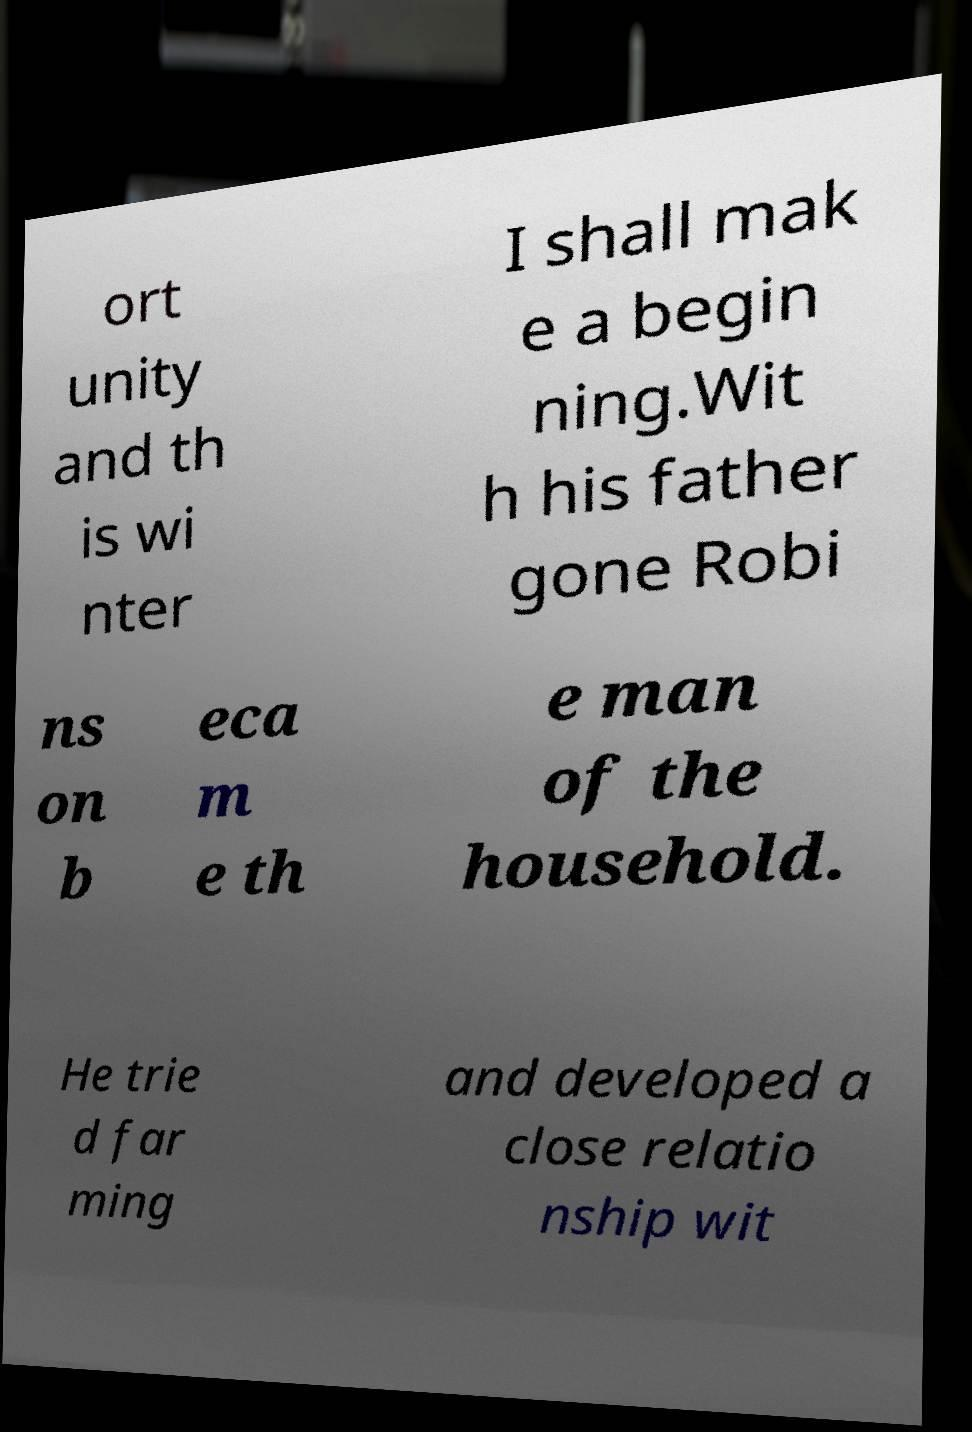Please read and relay the text visible in this image. What does it say? ort unity and th is wi nter I shall mak e a begin ning.Wit h his father gone Robi ns on b eca m e th e man of the household. He trie d far ming and developed a close relatio nship wit 